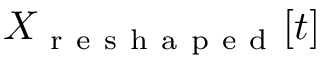<formula> <loc_0><loc_0><loc_500><loc_500>X _ { r e s h a p e d } [ t ]</formula> 